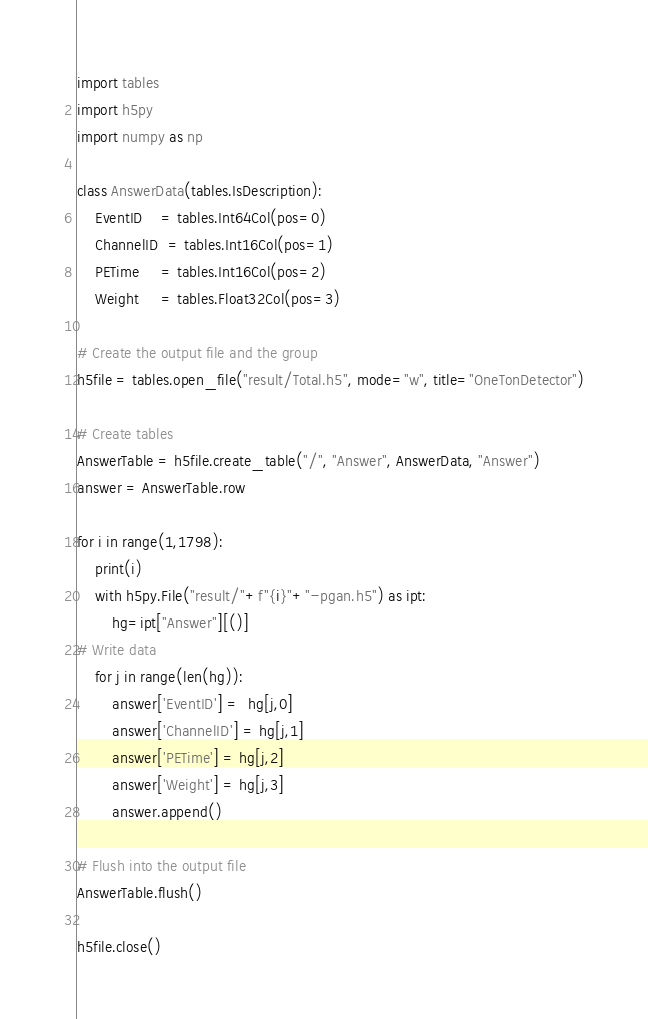Convert code to text. <code><loc_0><loc_0><loc_500><loc_500><_Python_>import tables
import h5py
import numpy as np

class AnswerData(tables.IsDescription):
    EventID    = tables.Int64Col(pos=0)
    ChannelID  = tables.Int16Col(pos=1)
    PETime     = tables.Int16Col(pos=2)
    Weight     = tables.Float32Col(pos=3)

# Create the output file and the group
h5file = tables.open_file("result/Total.h5", mode="w", title="OneTonDetector")

# Create tables
AnswerTable = h5file.create_table("/", "Answer", AnswerData, "Answer")
answer = AnswerTable.row

for i in range(1,1798):
    print(i)
    with h5py.File("result/"+f"{i}"+"-pgan.h5") as ipt:
        hg=ipt["Answer"][()]
# Write data 
    for j in range(len(hg)):
        answer['EventID'] =  hg[j,0]
        answer['ChannelID'] = hg[j,1]
        answer['PETime'] = hg[j,2]
        answer['Weight'] = hg[j,3]
        answer.append()

# Flush into the output file
AnswerTable.flush()

h5file.close()</code> 